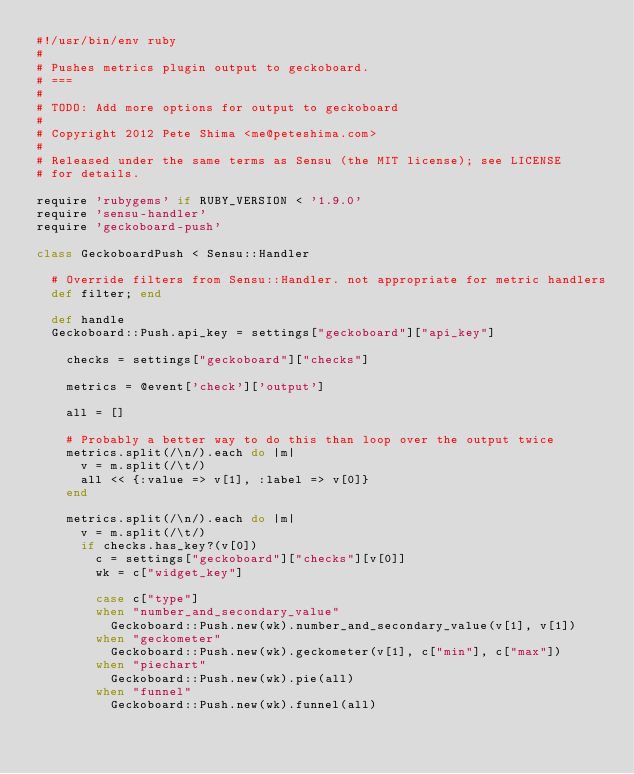<code> <loc_0><loc_0><loc_500><loc_500><_Ruby_>#!/usr/bin/env ruby
#
# Pushes metrics plugin output to geckoboard.
# ===
#
# TODO: Add more options for output to geckoboard
#
# Copyright 2012 Pete Shima <me@peteshima.com>
#
# Released under the same terms as Sensu (the MIT license); see LICENSE
# for details.

require 'rubygems' if RUBY_VERSION < '1.9.0'
require 'sensu-handler'
require 'geckoboard-push'

class GeckoboardPush < Sensu::Handler

  # Override filters from Sensu::Handler. not appropriate for metric handlers
  def filter; end

  def handle
  Geckoboard::Push.api_key = settings["geckoboard"]["api_key"]

    checks = settings["geckoboard"]["checks"]

    metrics = @event['check']['output']

    all = []

    # Probably a better way to do this than loop over the output twice
    metrics.split(/\n/).each do |m|
      v = m.split(/\t/)
      all << {:value => v[1], :label => v[0]}
    end

    metrics.split(/\n/).each do |m|
      v = m.split(/\t/)
      if checks.has_key?(v[0])
        c = settings["geckoboard"]["checks"][v[0]]
        wk = c["widget_key"]

        case c["type"]
        when "number_and_secondary_value"
          Geckoboard::Push.new(wk).number_and_secondary_value(v[1], v[1])
        when "geckometer"
          Geckoboard::Push.new(wk).geckometer(v[1], c["min"], c["max"])
        when "piechart"
          Geckoboard::Push.new(wk).pie(all)
        when "funnel"
          Geckoboard::Push.new(wk).funnel(all)</code> 